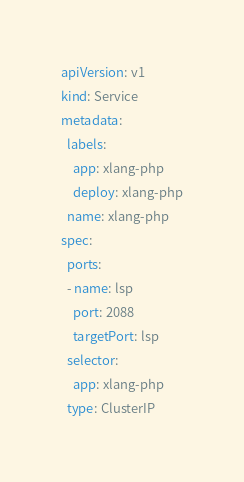<code> <loc_0><loc_0><loc_500><loc_500><_YAML_>apiVersion: v1
kind: Service
metadata:
  labels:
    app: xlang-php
    deploy: xlang-php
  name: xlang-php
spec:
  ports:
  - name: lsp
    port: 2088
    targetPort: lsp
  selector:
    app: xlang-php
  type: ClusterIP
</code> 